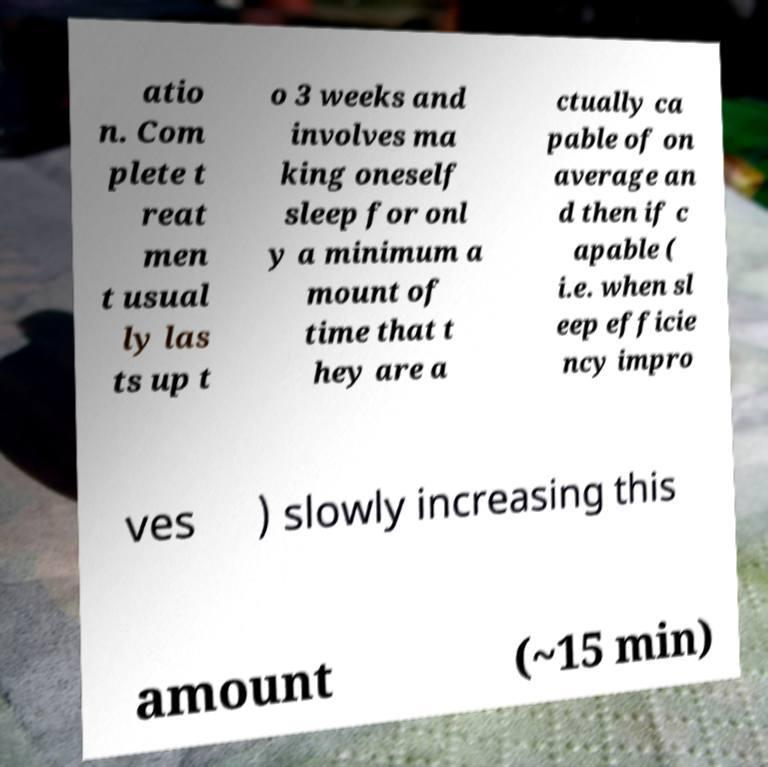Please read and relay the text visible in this image. What does it say? atio n. Com plete t reat men t usual ly las ts up t o 3 weeks and involves ma king oneself sleep for onl y a minimum a mount of time that t hey are a ctually ca pable of on average an d then if c apable ( i.e. when sl eep efficie ncy impro ves ) slowly increasing this amount (~15 min) 